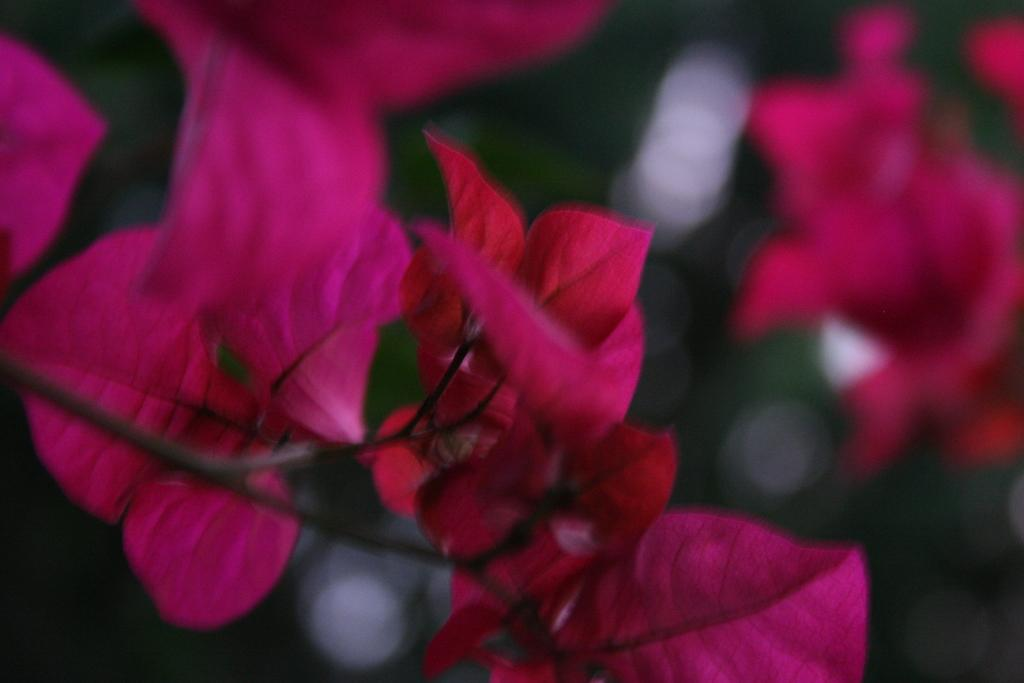What type of vegetation can be seen in the image? There are leaves in the image. Can you describe the background of the image? The background of the image is blurred. What type of nation is depicted in the image? There is no nation depicted in the image; it only features leaves and a blurred background. How many cans are visible in the image? There are no cans present in the image. 